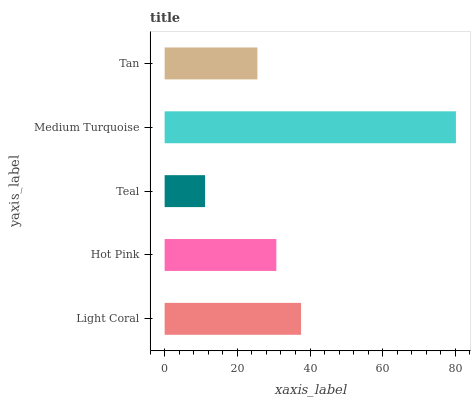Is Teal the minimum?
Answer yes or no. Yes. Is Medium Turquoise the maximum?
Answer yes or no. Yes. Is Hot Pink the minimum?
Answer yes or no. No. Is Hot Pink the maximum?
Answer yes or no. No. Is Light Coral greater than Hot Pink?
Answer yes or no. Yes. Is Hot Pink less than Light Coral?
Answer yes or no. Yes. Is Hot Pink greater than Light Coral?
Answer yes or no. No. Is Light Coral less than Hot Pink?
Answer yes or no. No. Is Hot Pink the high median?
Answer yes or no. Yes. Is Hot Pink the low median?
Answer yes or no. Yes. Is Light Coral the high median?
Answer yes or no. No. Is Tan the low median?
Answer yes or no. No. 